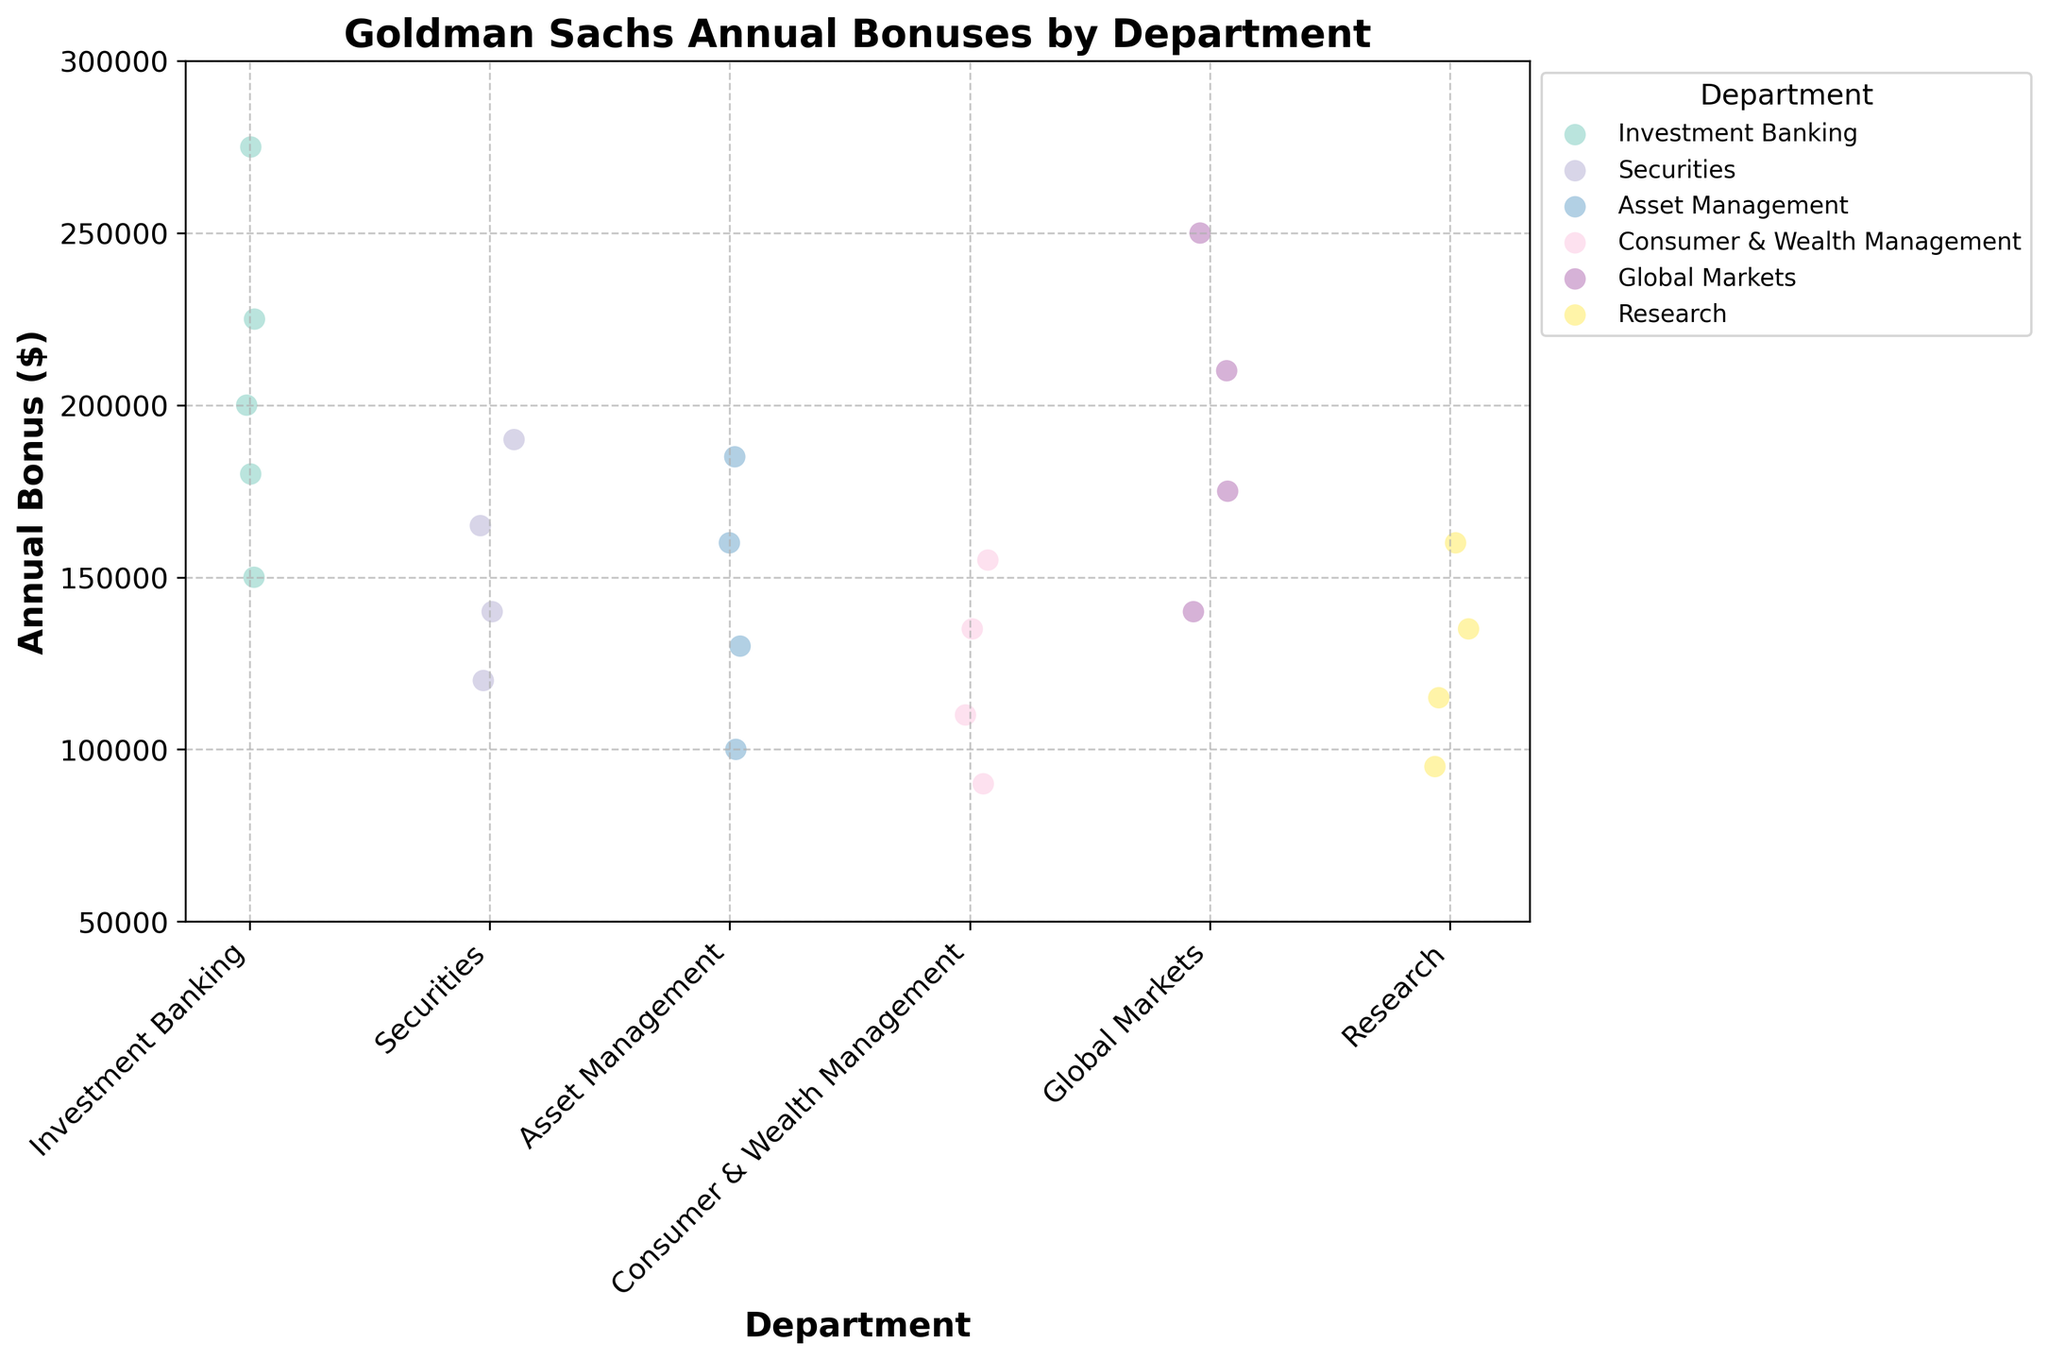What's the title of the figure? The title is usually placed at the top of the figure and provides a summary of what the chart is about. Here, it shows the reference to annual bonuses and departments at Goldman Sachs.
Answer: Goldman Sachs Annual Bonuses by Department What is the range of the y-axis for annual bonuses? The y-axis range can be determined by looking at the minimum and maximum values on the axis. Here, the minimum value is 50,000 and the maximum value is 300,000.
Answer: 50,000 to 300,000 Which department has the highest observed bonus value? By examining the data points scattered in the plot, the department with the data point that reaches the highest value in terms of annual bonuses can be determined.
Answer: Investment Banking How many departments are represented in the plot? The number of unique department labels on the x-axis can aid in determining the number of different departments represented in the plot.
Answer: 6 What is the average bonus in the Securities department? To find the average, identify the bonuses in the Securities department and calculate the arithmetic mean: (120000 + 140000 + 165000 + 190000) / 4 = 615000 / 4.
Answer: 153,750 Which department has the lowest maximum bonus value? By comparing the highest bonus values in each department, we identify that the department with the smallest peak bonus in the dataset is required.
Answer: Consumer & Wealth Management Is there more variability in bonuses within Investment Banking or Research? Variability can be assessed by comparing the spread of data points in the two departments. Investment Banking shows a wider range of values than Research.
Answer: Investment Banking What is the median bonus for the Global Markets department? To find the median, sort the bonuses for Global Markets and pick the middle value. The bonuses are 140000, 175000, 210000, 250000, so the median is (175000 + 210000) / 2.
Answer: 192,500 What are the two median bonus values in the Consumer & Wealth Management department? Sort the bonuses: 90000, 110000, 135000, 155000. The two middle values (since there are 4 data points) are 110000 and 135000.
Answer: 110,000 and 135,000 How much higher is the maximum bonus in the Investment Banking department compared to the maximum bonus in the Asset Management department? The maximum bonus in Investment Banking is 275000, and the maximum in Asset Management is 185000. The difference is 275000 - 185000.
Answer: 90,000 